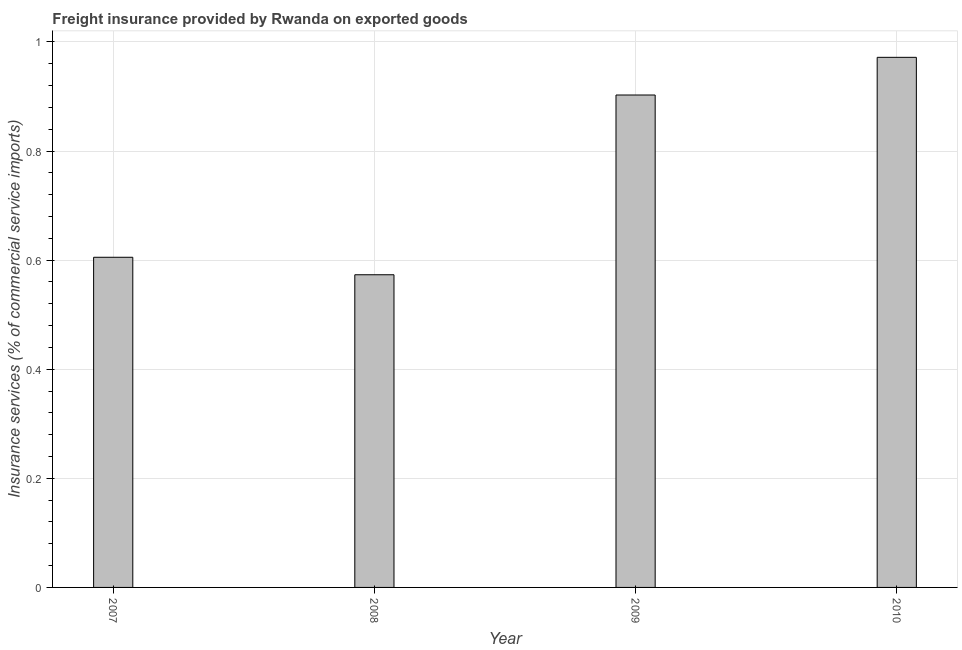What is the title of the graph?
Keep it short and to the point. Freight insurance provided by Rwanda on exported goods . What is the label or title of the Y-axis?
Offer a very short reply. Insurance services (% of commercial service imports). What is the freight insurance in 2010?
Offer a very short reply. 0.97. Across all years, what is the maximum freight insurance?
Give a very brief answer. 0.97. Across all years, what is the minimum freight insurance?
Make the answer very short. 0.57. In which year was the freight insurance minimum?
Your answer should be compact. 2008. What is the sum of the freight insurance?
Provide a succinct answer. 3.05. What is the difference between the freight insurance in 2009 and 2010?
Make the answer very short. -0.07. What is the average freight insurance per year?
Offer a terse response. 0.76. What is the median freight insurance?
Keep it short and to the point. 0.75. What is the ratio of the freight insurance in 2007 to that in 2008?
Provide a succinct answer. 1.06. Is the difference between the freight insurance in 2007 and 2008 greater than the difference between any two years?
Offer a terse response. No. What is the difference between the highest and the second highest freight insurance?
Your response must be concise. 0.07. Is the sum of the freight insurance in 2007 and 2008 greater than the maximum freight insurance across all years?
Give a very brief answer. Yes. What is the difference between the highest and the lowest freight insurance?
Provide a succinct answer. 0.4. How many years are there in the graph?
Ensure brevity in your answer.  4. What is the difference between two consecutive major ticks on the Y-axis?
Your answer should be very brief. 0.2. What is the Insurance services (% of commercial service imports) in 2007?
Make the answer very short. 0.61. What is the Insurance services (% of commercial service imports) of 2008?
Your response must be concise. 0.57. What is the Insurance services (% of commercial service imports) of 2009?
Give a very brief answer. 0.9. What is the Insurance services (% of commercial service imports) of 2010?
Offer a terse response. 0.97. What is the difference between the Insurance services (% of commercial service imports) in 2007 and 2008?
Your response must be concise. 0.03. What is the difference between the Insurance services (% of commercial service imports) in 2007 and 2009?
Make the answer very short. -0.3. What is the difference between the Insurance services (% of commercial service imports) in 2007 and 2010?
Your response must be concise. -0.37. What is the difference between the Insurance services (% of commercial service imports) in 2008 and 2009?
Make the answer very short. -0.33. What is the difference between the Insurance services (% of commercial service imports) in 2008 and 2010?
Give a very brief answer. -0.4. What is the difference between the Insurance services (% of commercial service imports) in 2009 and 2010?
Your response must be concise. -0.07. What is the ratio of the Insurance services (% of commercial service imports) in 2007 to that in 2008?
Your answer should be compact. 1.06. What is the ratio of the Insurance services (% of commercial service imports) in 2007 to that in 2009?
Keep it short and to the point. 0.67. What is the ratio of the Insurance services (% of commercial service imports) in 2007 to that in 2010?
Provide a succinct answer. 0.62. What is the ratio of the Insurance services (% of commercial service imports) in 2008 to that in 2009?
Give a very brief answer. 0.64. What is the ratio of the Insurance services (% of commercial service imports) in 2008 to that in 2010?
Keep it short and to the point. 0.59. What is the ratio of the Insurance services (% of commercial service imports) in 2009 to that in 2010?
Offer a terse response. 0.93. 